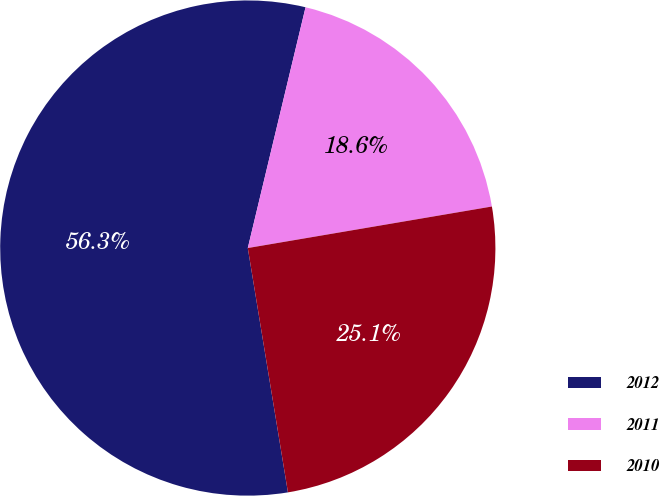Convert chart to OTSL. <chart><loc_0><loc_0><loc_500><loc_500><pie_chart><fcel>2012<fcel>2011<fcel>2010<nl><fcel>56.34%<fcel>18.57%<fcel>25.09%<nl></chart> 